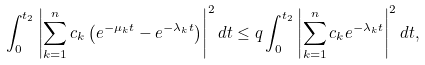Convert formula to latex. <formula><loc_0><loc_0><loc_500><loc_500>\int _ { 0 } ^ { t _ { 2 } } \left | \sum _ { k = 1 } ^ { n } c _ { k } \left ( e ^ { - \mu _ { k } t } - e ^ { - \lambda _ { k } t } \right ) \right | ^ { 2 } d t \leq q \int _ { 0 } ^ { t _ { 2 } } \left | \sum _ { k = 1 } ^ { n } c _ { k } e ^ { - \lambda _ { k } t } \right | ^ { 2 } d t ,</formula> 